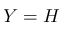Convert formula to latex. <formula><loc_0><loc_0><loc_500><loc_500>Y = H</formula> 